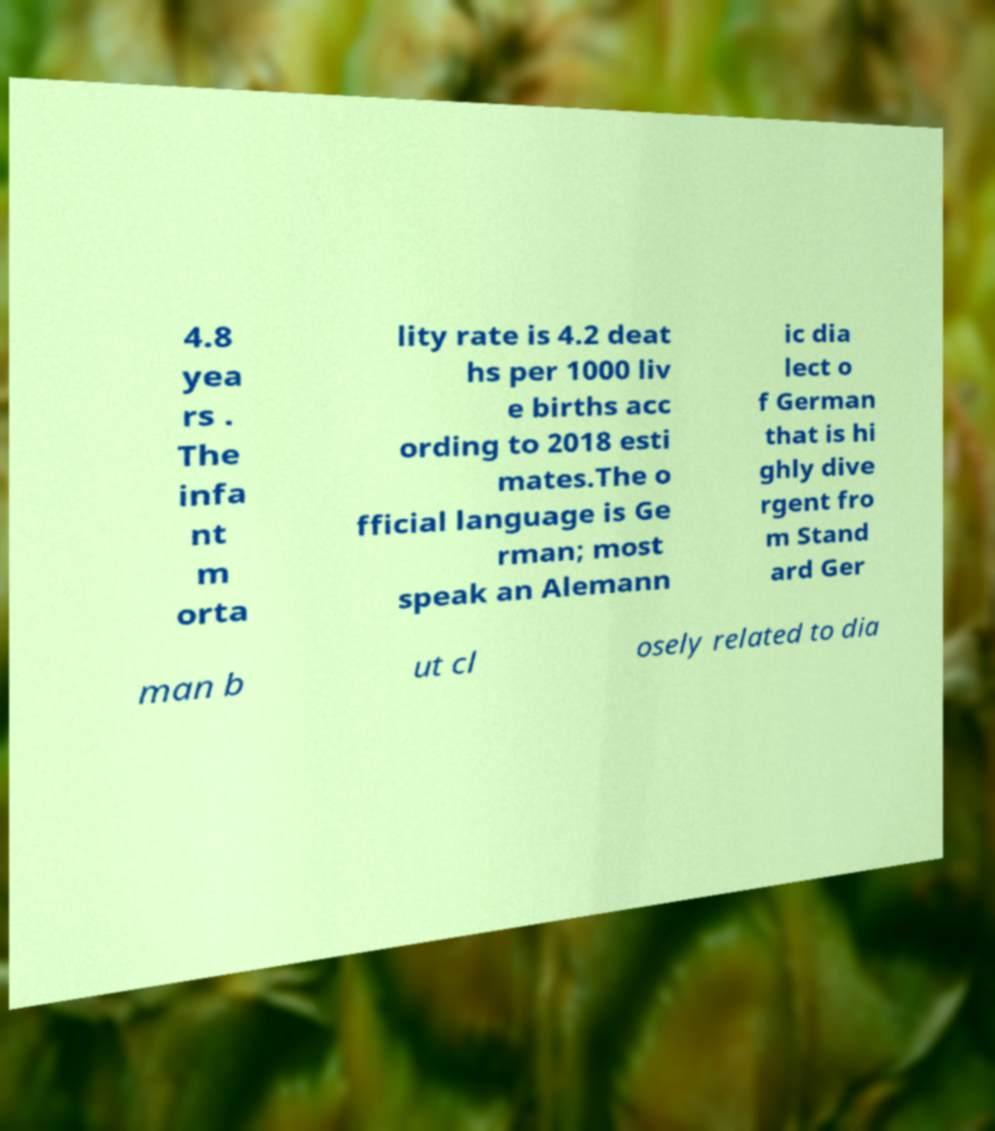I need the written content from this picture converted into text. Can you do that? 4.8 yea rs . The infa nt m orta lity rate is 4.2 deat hs per 1000 liv e births acc ording to 2018 esti mates.The o fficial language is Ge rman; most speak an Alemann ic dia lect o f German that is hi ghly dive rgent fro m Stand ard Ger man b ut cl osely related to dia 